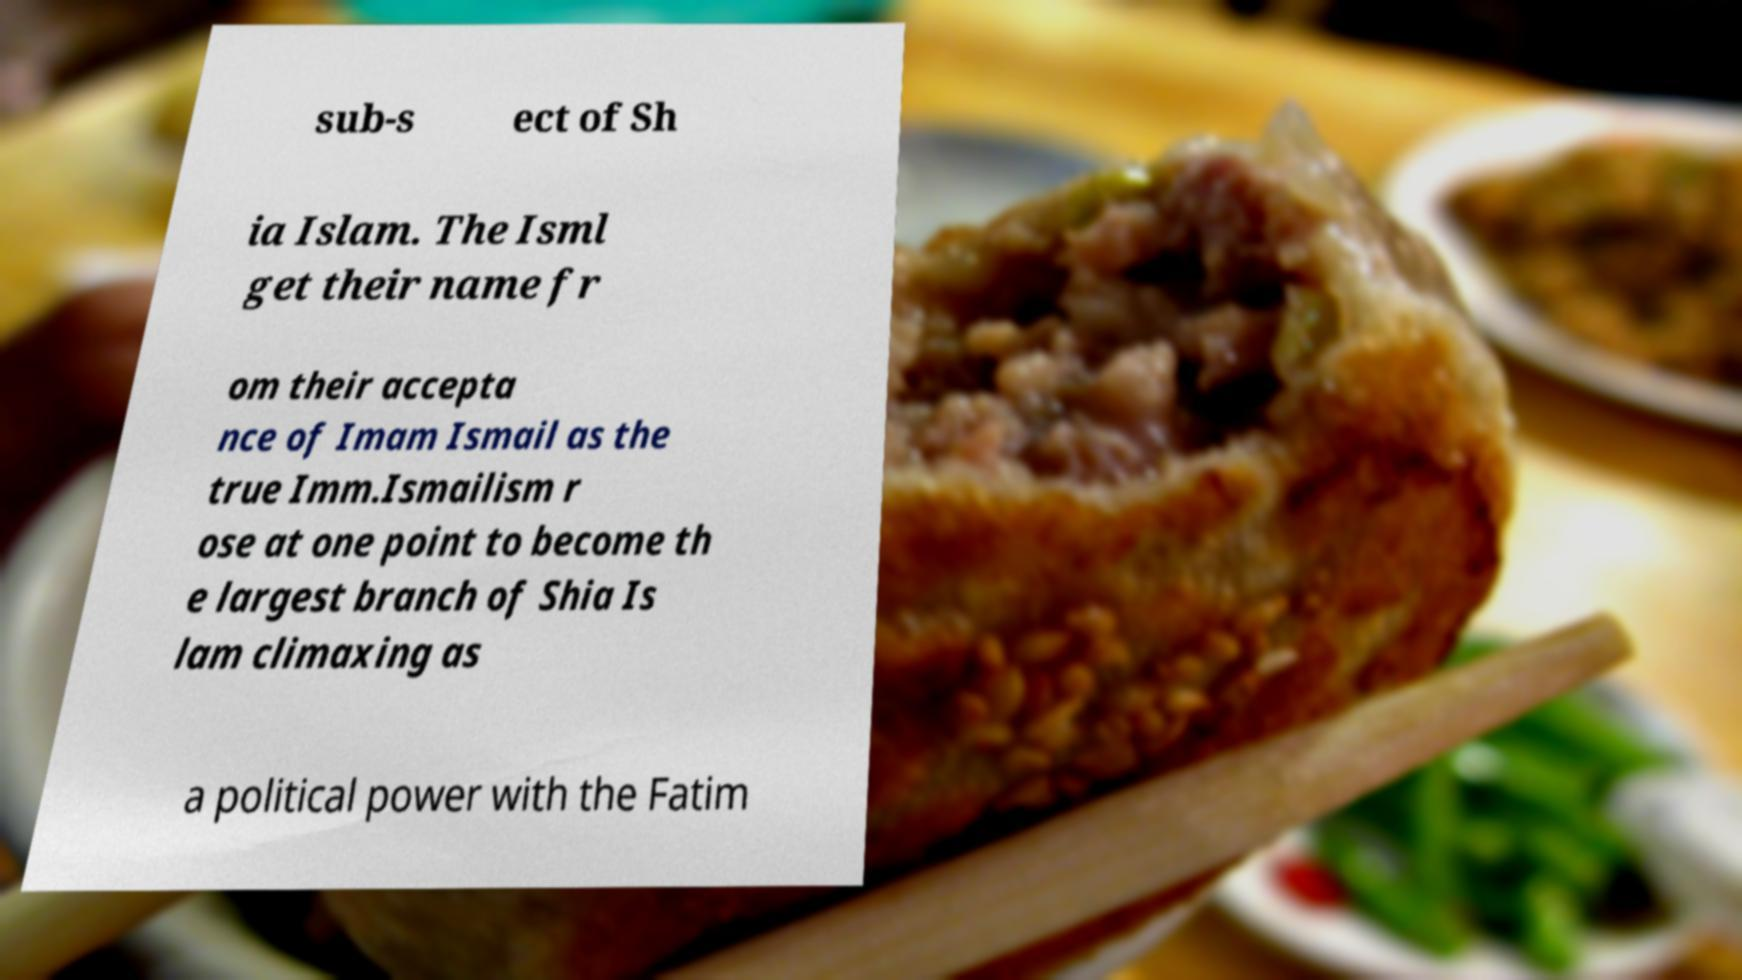For documentation purposes, I need the text within this image transcribed. Could you provide that? sub-s ect of Sh ia Islam. The Isml get their name fr om their accepta nce of Imam Ismail as the true Imm.Ismailism r ose at one point to become th e largest branch of Shia Is lam climaxing as a political power with the Fatim 